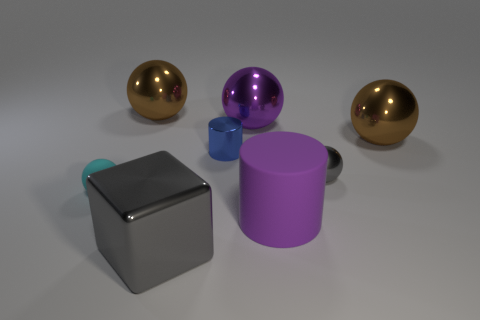What is the color of the metallic thing that is the same shape as the purple rubber thing?
Offer a terse response. Blue. Does the tiny ball behind the tiny cyan rubber ball have the same color as the matte sphere?
Keep it short and to the point. No. How many things are either cylinders that are behind the big purple matte cylinder or tiny blue rubber cylinders?
Provide a short and direct response. 1. What is the thing left of the big shiny thing that is left of the gray object in front of the small cyan ball made of?
Provide a succinct answer. Rubber. Are there more purple rubber things that are behind the small gray sphere than gray objects that are behind the big purple metal ball?
Offer a very short reply. No. What number of cubes are tiny blue objects or tiny gray shiny objects?
Give a very brief answer. 0. How many small blue metal objects are behind the big brown object behind the big ball on the right side of the purple cylinder?
Make the answer very short. 0. There is a big thing that is the same color as the matte cylinder; what is it made of?
Your response must be concise. Metal. Is the number of big metallic balls greater than the number of tiny metallic cylinders?
Offer a very short reply. Yes. Does the metal cube have the same size as the metallic cylinder?
Provide a short and direct response. No. 